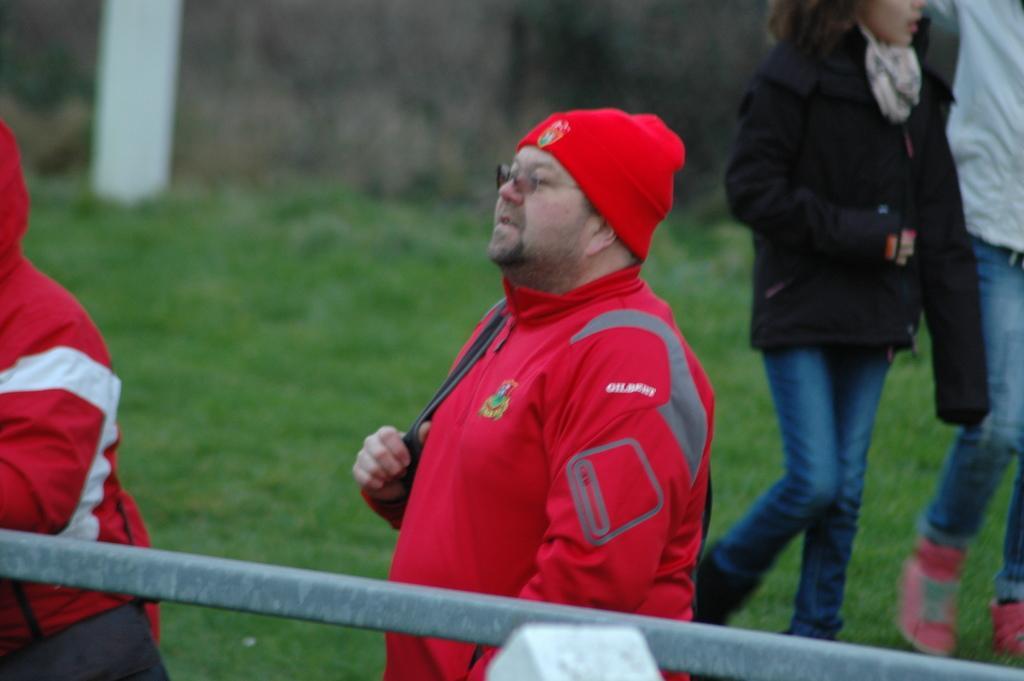Could you give a brief overview of what you see in this image? In this image we can see people. At the bottom of the image there is grass. There is a pole. 